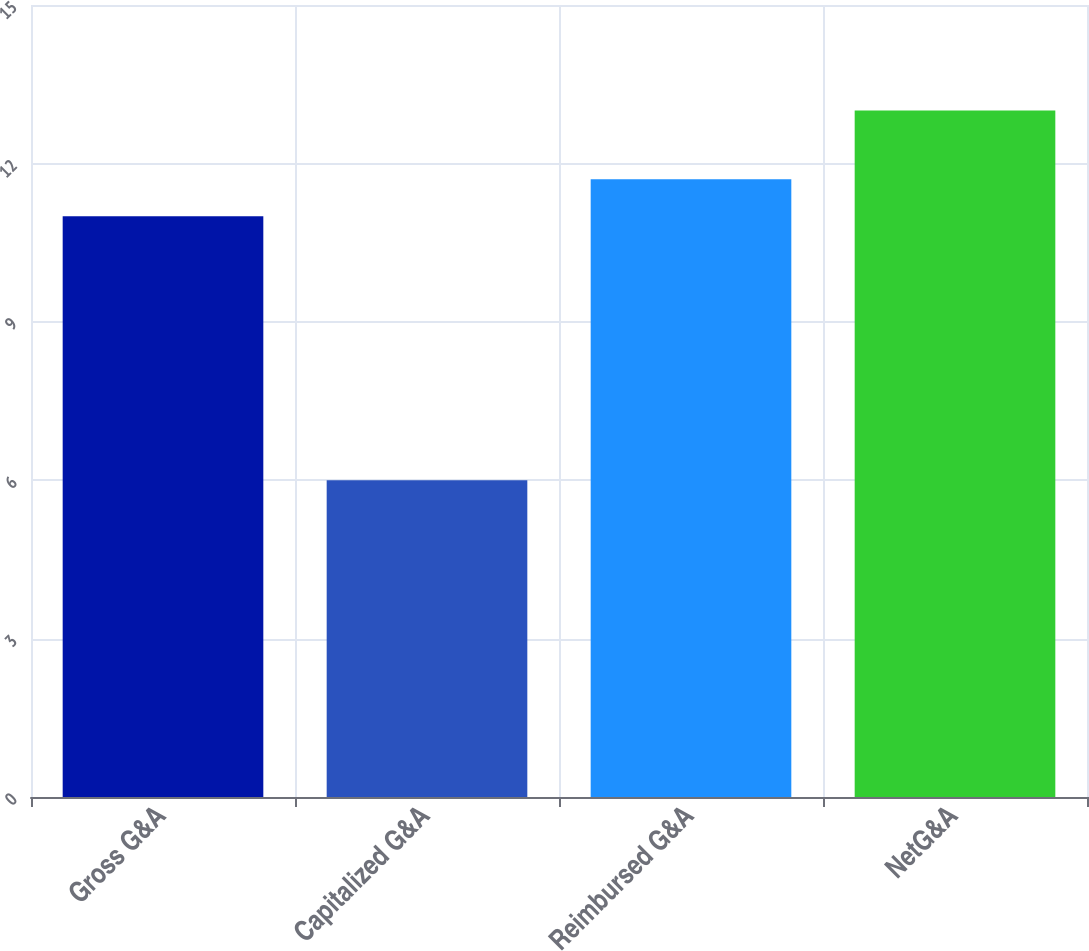Convert chart to OTSL. <chart><loc_0><loc_0><loc_500><loc_500><bar_chart><fcel>Gross G&A<fcel>Capitalized G&A<fcel>Reimbursed G&A<fcel>NetG&A<nl><fcel>11<fcel>6<fcel>11.7<fcel>13<nl></chart> 